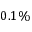<formula> <loc_0><loc_0><loc_500><loc_500>0 . 1 \%</formula> 